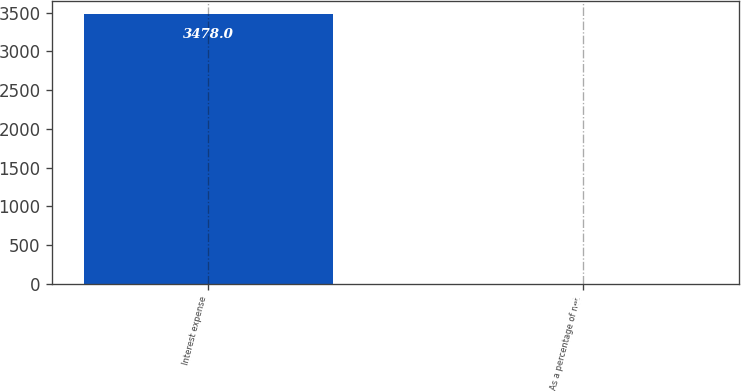<chart> <loc_0><loc_0><loc_500><loc_500><bar_chart><fcel>Interest expense<fcel>As a percentage of net<nl><fcel>3478<fcel>0.1<nl></chart> 